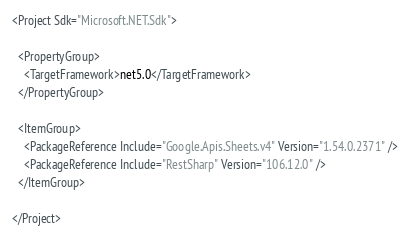<code> <loc_0><loc_0><loc_500><loc_500><_XML_><Project Sdk="Microsoft.NET.Sdk">

  <PropertyGroup>
    <TargetFramework>net5.0</TargetFramework>
  </PropertyGroup>

  <ItemGroup>
    <PackageReference Include="Google.Apis.Sheets.v4" Version="1.54.0.2371" />
    <PackageReference Include="RestSharp" Version="106.12.0" />
  </ItemGroup>

</Project>
</code> 